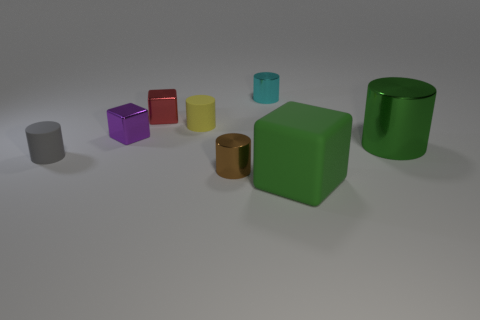Is the big rubber block the same color as the big cylinder?
Your response must be concise. Yes. What is the size of the metal thing that is the same color as the large matte cube?
Give a very brief answer. Large. What material is the brown cylinder that is the same size as the gray matte thing?
Make the answer very short. Metal. Does the green object in front of the small gray cylinder have the same size as the rubber thing left of the tiny red metallic object?
Offer a terse response. No. Is there a small brown thing made of the same material as the green cylinder?
Your response must be concise. Yes. What number of things are either tiny objects that are on the right side of the small gray rubber cylinder or green objects?
Offer a terse response. 7. Is the material of the object to the right of the large cube the same as the small yellow cylinder?
Keep it short and to the point. No. Is the purple metallic object the same shape as the tiny gray thing?
Offer a very short reply. No. There is a green thing that is behind the big green rubber cube; how many cyan metal cylinders are right of it?
Ensure brevity in your answer.  0. There is a brown thing that is the same shape as the tiny gray object; what is it made of?
Ensure brevity in your answer.  Metal. 